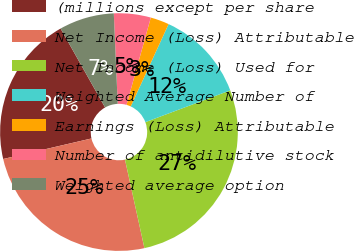Convert chart to OTSL. <chart><loc_0><loc_0><loc_500><loc_500><pie_chart><fcel>(millions except per share<fcel>Net Income (Loss) Attributable<fcel>Net Income (Loss) Used for<fcel>Weighted Average Number of<fcel>Earnings (Loss) Attributable<fcel>Number of antidilutive stock<fcel>Weighted average option<nl><fcel>20.47%<fcel>24.8%<fcel>27.27%<fcel>12.43%<fcel>2.54%<fcel>5.01%<fcel>7.48%<nl></chart> 